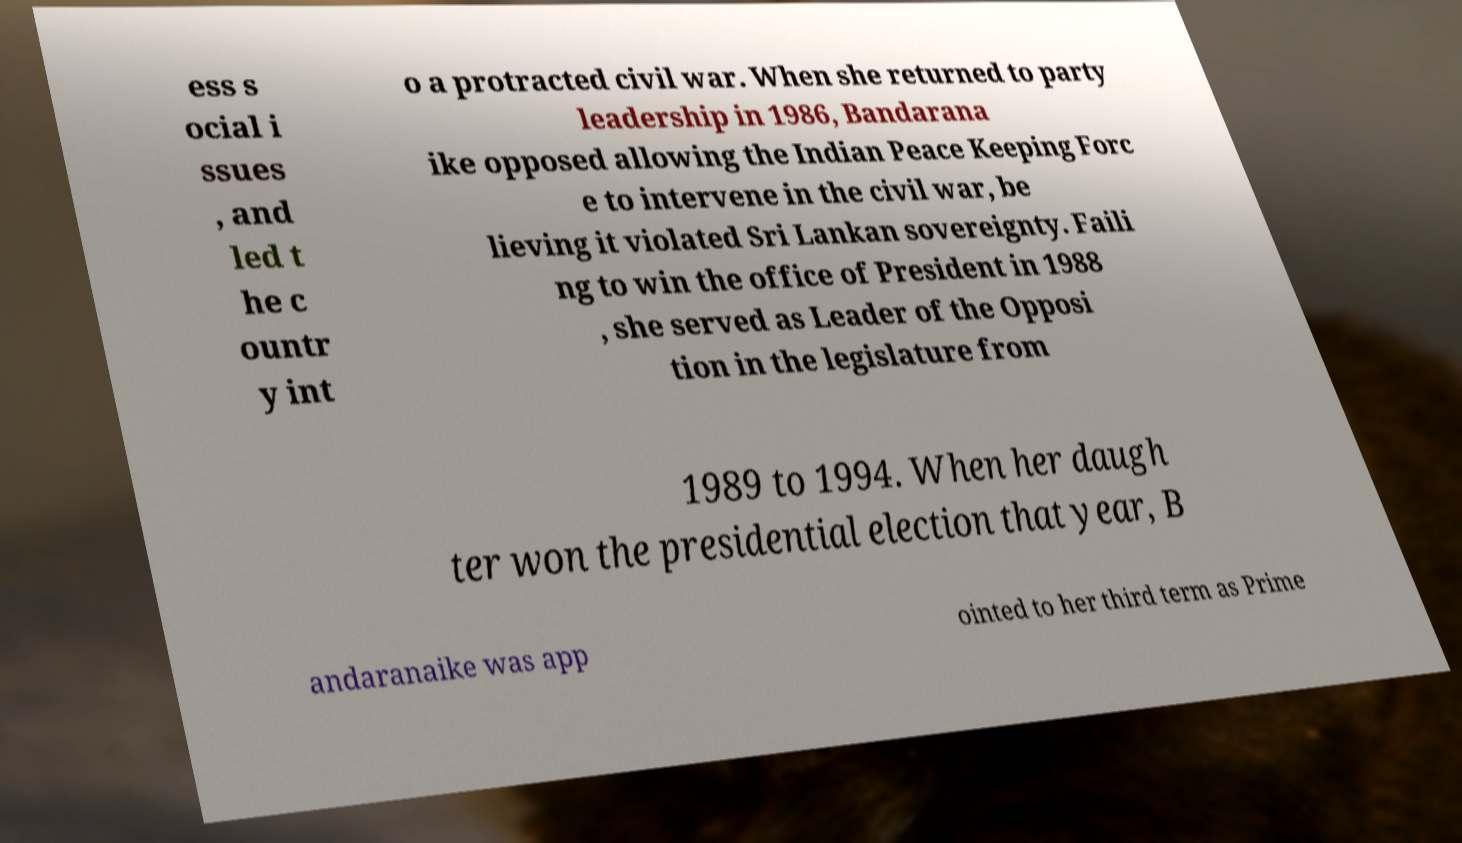I need the written content from this picture converted into text. Can you do that? ess s ocial i ssues , and led t he c ountr y int o a protracted civil war. When she returned to party leadership in 1986, Bandarana ike opposed allowing the Indian Peace Keeping Forc e to intervene in the civil war, be lieving it violated Sri Lankan sovereignty. Faili ng to win the office of President in 1988 , she served as Leader of the Opposi tion in the legislature from 1989 to 1994. When her daugh ter won the presidential election that year, B andaranaike was app ointed to her third term as Prime 